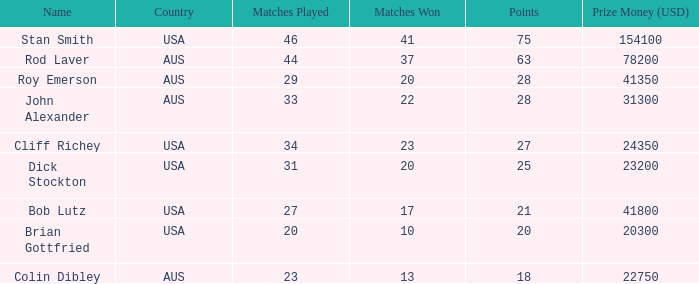In how many contests did colin dibley achieve victory? 13.0. 